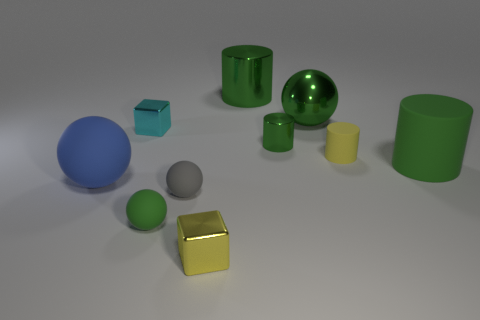The large blue thing is what shape?
Your response must be concise. Sphere. Is the number of large green rubber cylinders in front of the green rubber ball greater than the number of small green matte things that are behind the blue rubber object?
Offer a very short reply. No. How many other things are the same size as the cyan cube?
Give a very brief answer. 5. What is the material of the large thing that is both on the right side of the small cyan metal thing and in front of the yellow cylinder?
Give a very brief answer. Rubber. What material is the other tiny thing that is the same shape as the gray object?
Offer a terse response. Rubber. There is a block that is in front of the tiny cube that is behind the big matte sphere; how many tiny yellow things are behind it?
Your response must be concise. 1. Is there any other thing of the same color as the large matte cylinder?
Offer a terse response. Yes. What number of balls are both to the left of the cyan shiny block and right of the small yellow shiny cube?
Provide a succinct answer. 0. Does the green sphere behind the tiny green rubber object have the same size as the matte ball behind the small gray rubber sphere?
Your response must be concise. Yes. How many things are small gray objects that are left of the large green rubber cylinder or blue matte balls?
Your response must be concise. 2. 